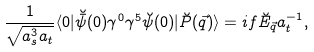<formula> <loc_0><loc_0><loc_500><loc_500>\frac { 1 } { \sqrt { a _ { s } ^ { 3 } a _ { t } } } \langle 0 | \breve { \bar { \psi } } ( 0 ) \gamma ^ { 0 } \gamma ^ { 5 } \breve { \psi } ( 0 ) | \breve { P } ( \vec { q } ) \rangle = i f \breve { E } _ { \vec { q } } a _ { t } ^ { - 1 } ,</formula> 